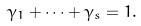<formula> <loc_0><loc_0><loc_500><loc_500>\gamma _ { 1 } + \cdots + \gamma _ { s } = 1 .</formula> 